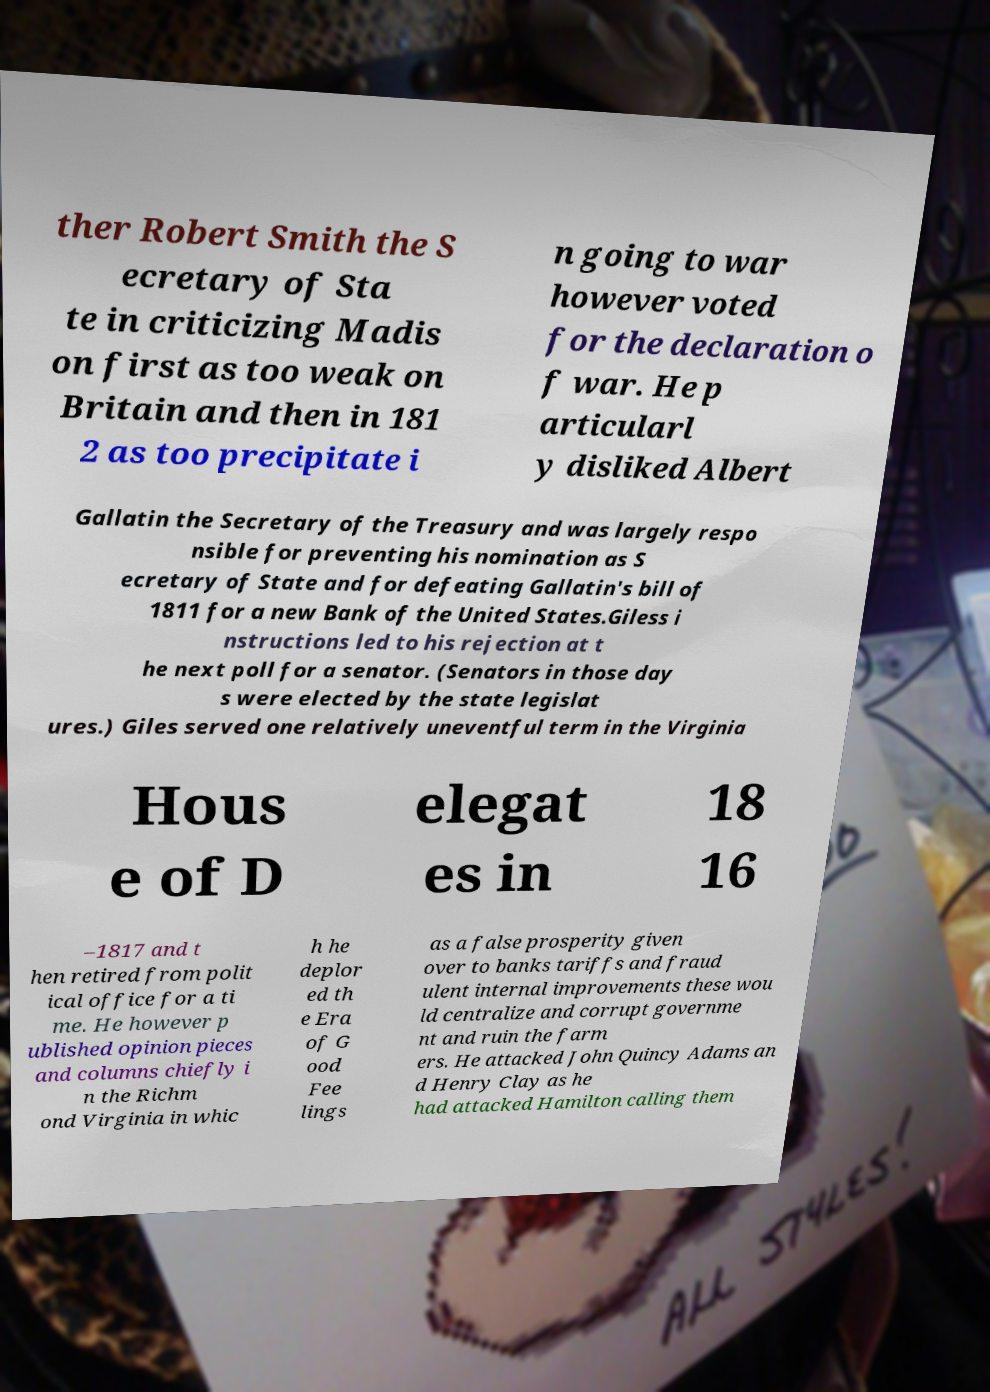Can you accurately transcribe the text from the provided image for me? ther Robert Smith the S ecretary of Sta te in criticizing Madis on first as too weak on Britain and then in 181 2 as too precipitate i n going to war however voted for the declaration o f war. He p articularl y disliked Albert Gallatin the Secretary of the Treasury and was largely respo nsible for preventing his nomination as S ecretary of State and for defeating Gallatin's bill of 1811 for a new Bank of the United States.Giless i nstructions led to his rejection at t he next poll for a senator. (Senators in those day s were elected by the state legislat ures.) Giles served one relatively uneventful term in the Virginia Hous e of D elegat es in 18 16 –1817 and t hen retired from polit ical office for a ti me. He however p ublished opinion pieces and columns chiefly i n the Richm ond Virginia in whic h he deplor ed th e Era of G ood Fee lings as a false prosperity given over to banks tariffs and fraud ulent internal improvements these wou ld centralize and corrupt governme nt and ruin the farm ers. He attacked John Quincy Adams an d Henry Clay as he had attacked Hamilton calling them 